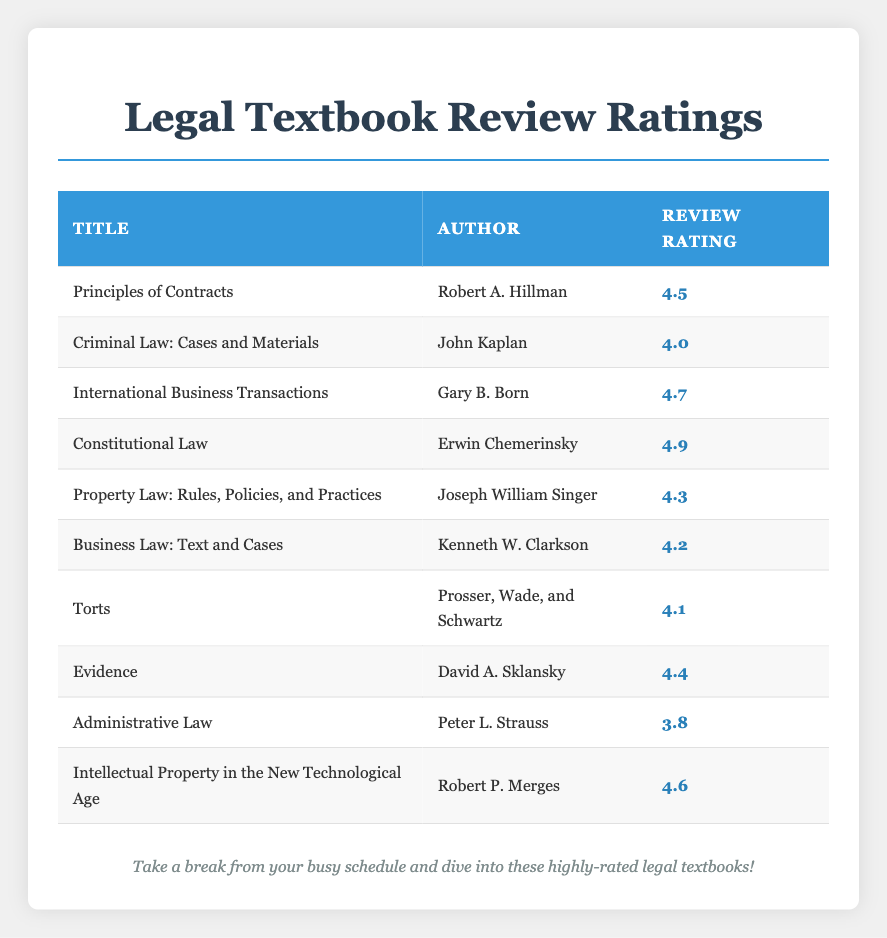What is the highest review rating among the textbooks? The highest review rating is found by scanning through the "Review Rating" column and identifying the maximum value. The review rating of "Constitutional Law" by Erwin Chemerinsky is 4.9, which is the highest among all listed textbooks.
Answer: 4.9 Which textbook has a review rating of 4.6? By checking the "Review Rating" column for the value of 4.6, I see that "Intellectual Property in the New Technological Age" by Robert P. Merges corresponds to this rating.
Answer: Intellectual Property in the New Technological Age How many textbooks have a review rating below 4? To find this, I need to count the number of entries in the "Review Rating" column that are less than 4. Scanning through the ratings, only "Administrative Law" by Peter L. Strauss has a rating below 4 (which is 3.8). Thus, there is 1 textbook in total.
Answer: 1 What is the average review rating of all textbooks listed? First, sum all the review ratings: (4.5 + 4.0 + 4.7 + 4.9 + 4.3 + 4.2 + 4.1 + 4.4 + 3.8 + 4.6) = 44.6. There are 10 textbooks in total, so to find the average, divide the total rating by the number of textbooks: 44.6 / 10 = 4.46.
Answer: 4.46 Is “Torts” rated higher than “Administrative Law”? To answer this, I check the review ratings of both textbooks: "Torts" by Prosser, Wade, and Schwartz has a rating of 4.1, while "Administrative Law" by Peter L. Strauss has a rating of 3.8. Since 4.1 is greater than 3.8, the answer is yes.
Answer: Yes Which author has the lowest-rated book? By examining the data, I find that "Administrative Law" by Peter L. Strauss has the lowest review rating of 3.8 among all entries in the table.
Answer: Peter L. Strauss How many authors have textbooks with a review rating of 4.5 or higher? To determine this, I need to identify which textbooks have a rating of 4.5 or higher. These are "Principles of Contracts" (4.5), "International Business Transactions" (4.7), "Constitutional Law" (4.9), "Intellectual Property in the New Technological Age" (4.6), "Evidence" (4.4). The authors Robert A. Hillman, Gary B. Born, Erwin Chemerinsky, Robert P. Merges, and David A. Sklansky correspond to these textbooks. There are a total of 5 unique authors in this group.
Answer: 5 How many textbooks have a review rating in the range of 4.0 to 4.3? I check the "Review Rating" column for ratings between 4.0 and 4.3. The textbooks "Criminal Law: Cases and Materials" (4.0), "Property Law: Rules, Policies, and Practices" (4.3), and "Business Law: Text and Cases" (4.2) fall within this range. Therefore, there are 3 textbooks that meet the criteria.
Answer: 3 Is the average review rating of the textbooks above 4? To find this, we previously calculated the average rating to be 4.46. Since 4.46 is greater than 4, the answer is yes.
Answer: Yes 